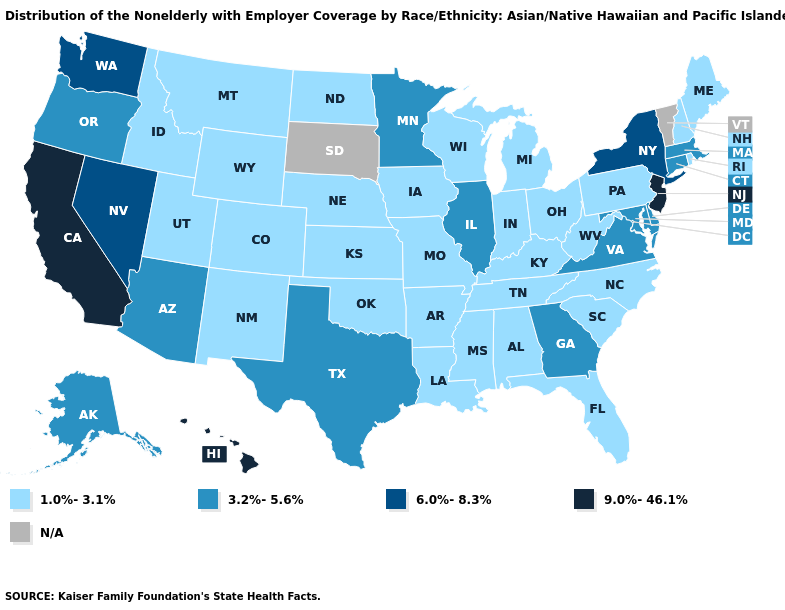Name the states that have a value in the range 3.2%-5.6%?
Give a very brief answer. Alaska, Arizona, Connecticut, Delaware, Georgia, Illinois, Maryland, Massachusetts, Minnesota, Oregon, Texas, Virginia. What is the value of Colorado?
Give a very brief answer. 1.0%-3.1%. Name the states that have a value in the range 1.0%-3.1%?
Short answer required. Alabama, Arkansas, Colorado, Florida, Idaho, Indiana, Iowa, Kansas, Kentucky, Louisiana, Maine, Michigan, Mississippi, Missouri, Montana, Nebraska, New Hampshire, New Mexico, North Carolina, North Dakota, Ohio, Oklahoma, Pennsylvania, Rhode Island, South Carolina, Tennessee, Utah, West Virginia, Wisconsin, Wyoming. What is the value of Nevada?
Give a very brief answer. 6.0%-8.3%. Name the states that have a value in the range 3.2%-5.6%?
Concise answer only. Alaska, Arizona, Connecticut, Delaware, Georgia, Illinois, Maryland, Massachusetts, Minnesota, Oregon, Texas, Virginia. Does the map have missing data?
Keep it brief. Yes. What is the highest value in the South ?
Concise answer only. 3.2%-5.6%. Which states hav the highest value in the Northeast?
Give a very brief answer. New Jersey. Does the first symbol in the legend represent the smallest category?
Concise answer only. Yes. Which states hav the highest value in the MidWest?
Short answer required. Illinois, Minnesota. Is the legend a continuous bar?
Be succinct. No. What is the lowest value in states that border Colorado?
Concise answer only. 1.0%-3.1%. What is the highest value in states that border Texas?
Answer briefly. 1.0%-3.1%. Name the states that have a value in the range 1.0%-3.1%?
Quick response, please. Alabama, Arkansas, Colorado, Florida, Idaho, Indiana, Iowa, Kansas, Kentucky, Louisiana, Maine, Michigan, Mississippi, Missouri, Montana, Nebraska, New Hampshire, New Mexico, North Carolina, North Dakota, Ohio, Oklahoma, Pennsylvania, Rhode Island, South Carolina, Tennessee, Utah, West Virginia, Wisconsin, Wyoming. What is the lowest value in states that border Kansas?
Answer briefly. 1.0%-3.1%. 